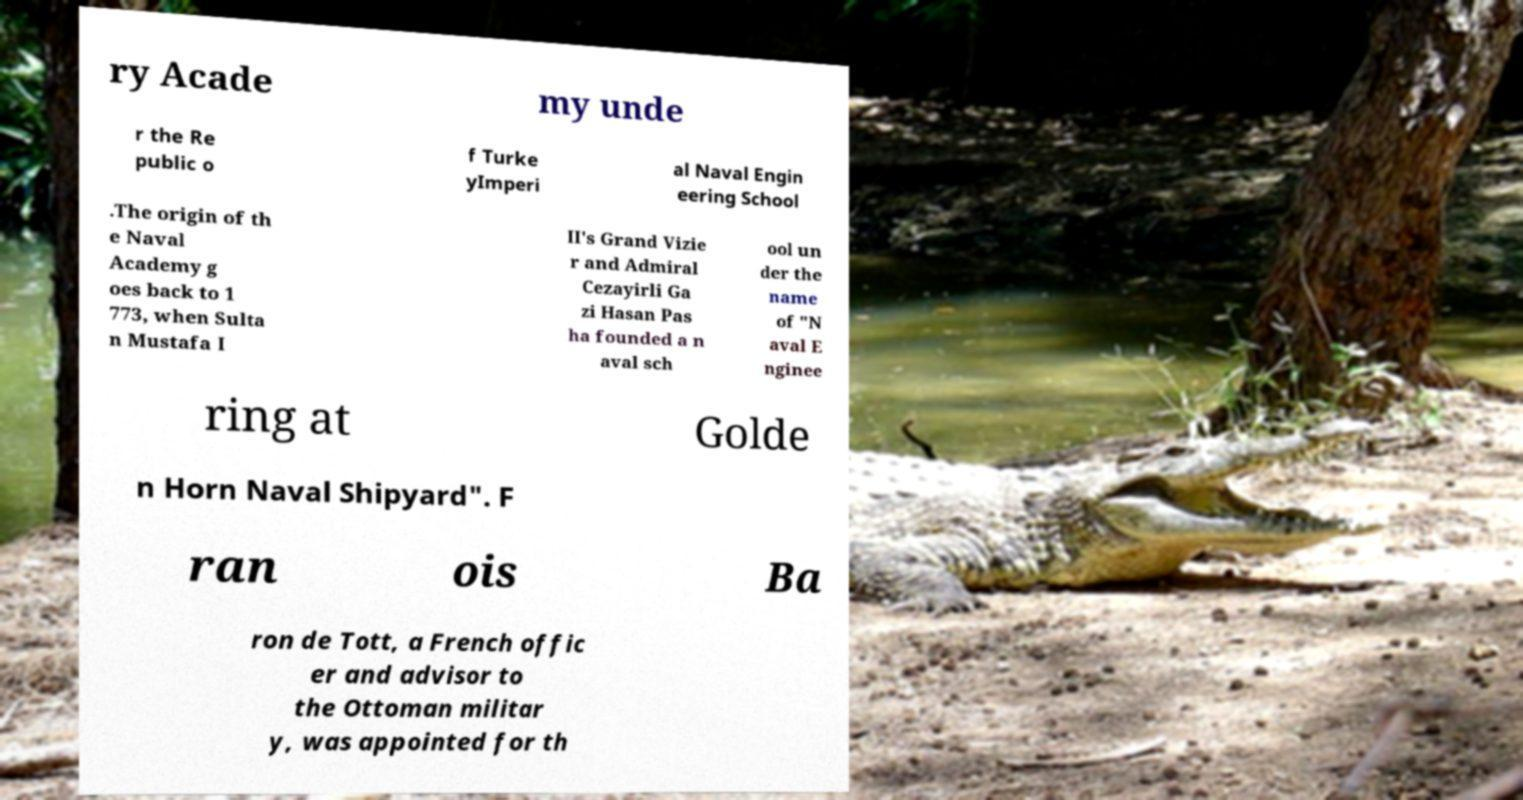Can you read and provide the text displayed in the image?This photo seems to have some interesting text. Can you extract and type it out for me? ry Acade my unde r the Re public o f Turke yImperi al Naval Engin eering School .The origin of th e Naval Academy g oes back to 1 773, when Sulta n Mustafa I II's Grand Vizie r and Admiral Cezayirli Ga zi Hasan Pas ha founded a n aval sch ool un der the name of "N aval E nginee ring at Golde n Horn Naval Shipyard". F ran ois Ba ron de Tott, a French offic er and advisor to the Ottoman militar y, was appointed for th 